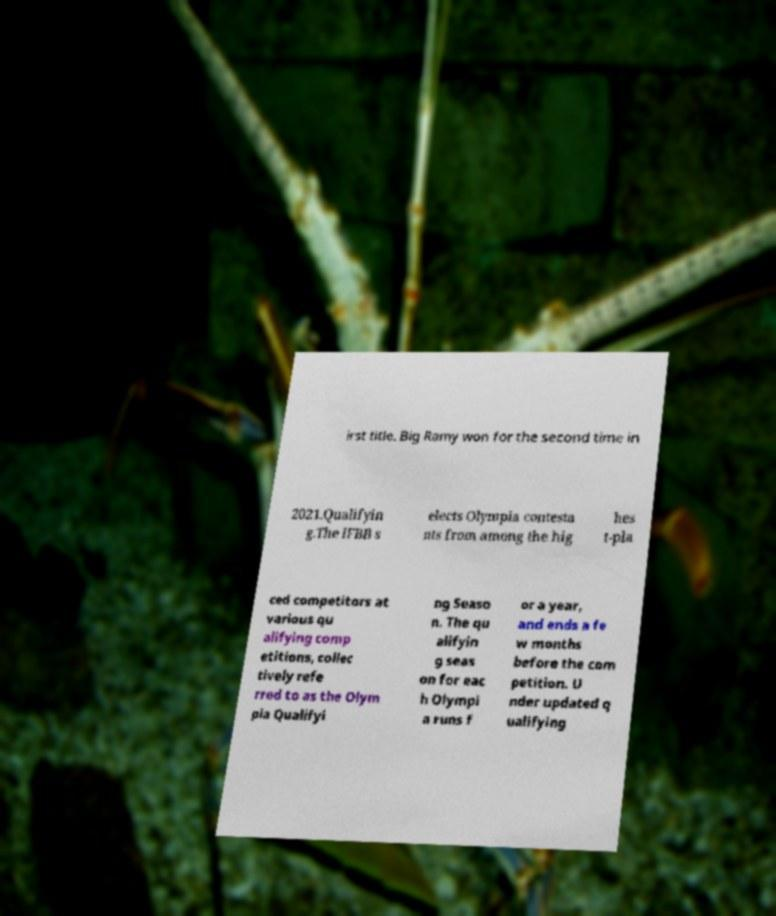What messages or text are displayed in this image? I need them in a readable, typed format. irst title. Big Ramy won for the second time in 2021.Qualifyin g.The IFBB s elects Olympia contesta nts from among the hig hes t-pla ced competitors at various qu alifying comp etitions, collec tively refe rred to as the Olym pia Qualifyi ng Seaso n. The qu alifyin g seas on for eac h Olympi a runs f or a year, and ends a fe w months before the com petition. U nder updated q ualifying 